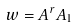Convert formula to latex. <formula><loc_0><loc_0><loc_500><loc_500>w = A ^ { r } A _ { 1 }</formula> 